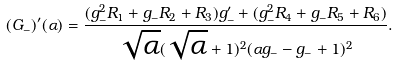<formula> <loc_0><loc_0><loc_500><loc_500>( G _ { - } ) ^ { \prime } ( \alpha ) = \frac { ( g _ { - } ^ { 2 } R _ { 1 } + g _ { - } R _ { 2 } + R _ { 3 } ) g _ { - } ^ { \prime } + ( g _ { - } ^ { 2 } R _ { 4 } + g _ { - } R _ { 5 } + R _ { 6 } ) } { \sqrt { \alpha } ( \sqrt { \alpha } + 1 ) ^ { 2 } ( \alpha g _ { - } - g _ { - } + 1 ) ^ { 2 } } .</formula> 